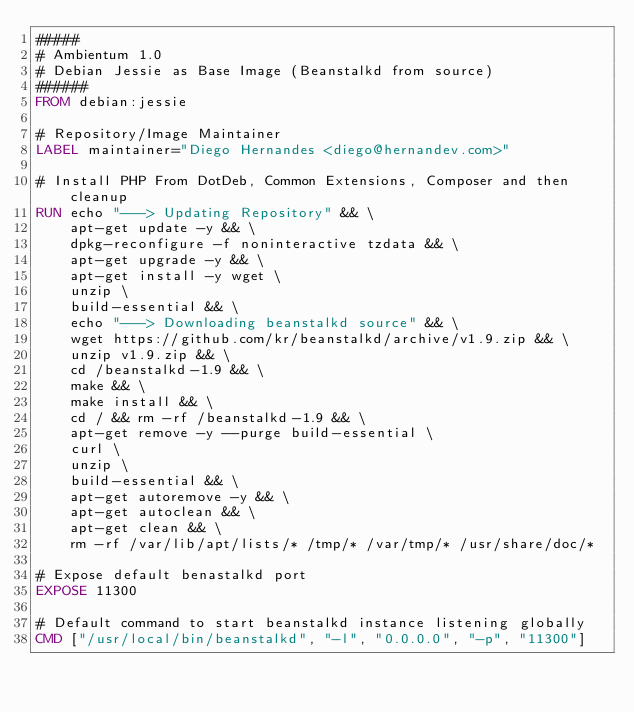Convert code to text. <code><loc_0><loc_0><loc_500><loc_500><_Dockerfile_>#####
# Ambientum 1.0
# Debian Jessie as Base Image (Beanstalkd from source)
######
FROM debian:jessie

# Repository/Image Maintainer
LABEL maintainer="Diego Hernandes <diego@hernandev.com>"

# Install PHP From DotDeb, Common Extensions, Composer and then cleanup
RUN echo "---> Updating Repository" && \
    apt-get update -y && \
    dpkg-reconfigure -f noninteractive tzdata && \
    apt-get upgrade -y && \
    apt-get install -y wget \
    unzip \
    build-essential && \
    echo "---> Downloading beanstalkd source" && \
    wget https://github.com/kr/beanstalkd/archive/v1.9.zip && \
    unzip v1.9.zip && \
    cd /beanstalkd-1.9 && \
    make && \
    make install && \
    cd / && rm -rf /beanstalkd-1.9 && \
    apt-get remove -y --purge build-essential \
    curl \
    unzip \
    build-essential && \
    apt-get autoremove -y && \
    apt-get autoclean && \
    apt-get clean && \
    rm -rf /var/lib/apt/lists/* /tmp/* /var/tmp/* /usr/share/doc/*

# Expose default benastalkd port
EXPOSE 11300

# Default command to start beanstalkd instance listening globally
CMD ["/usr/local/bin/beanstalkd", "-l", "0.0.0.0", "-p", "11300"]
</code> 